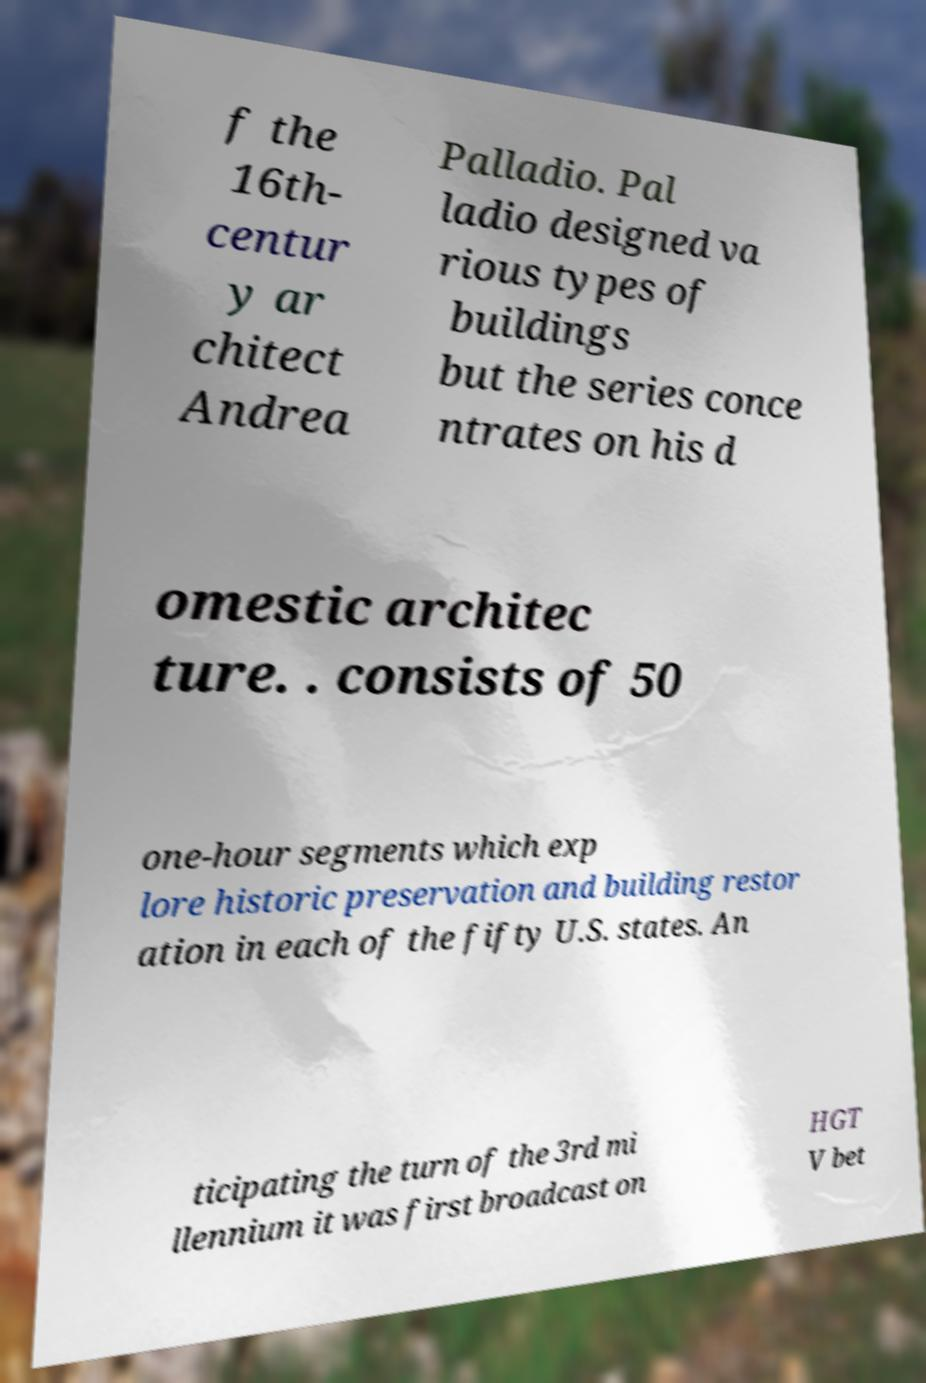What messages or text are displayed in this image? I need them in a readable, typed format. f the 16th- centur y ar chitect Andrea Palladio. Pal ladio designed va rious types of buildings but the series conce ntrates on his d omestic architec ture. . consists of 50 one-hour segments which exp lore historic preservation and building restor ation in each of the fifty U.S. states. An ticipating the turn of the 3rd mi llennium it was first broadcast on HGT V bet 